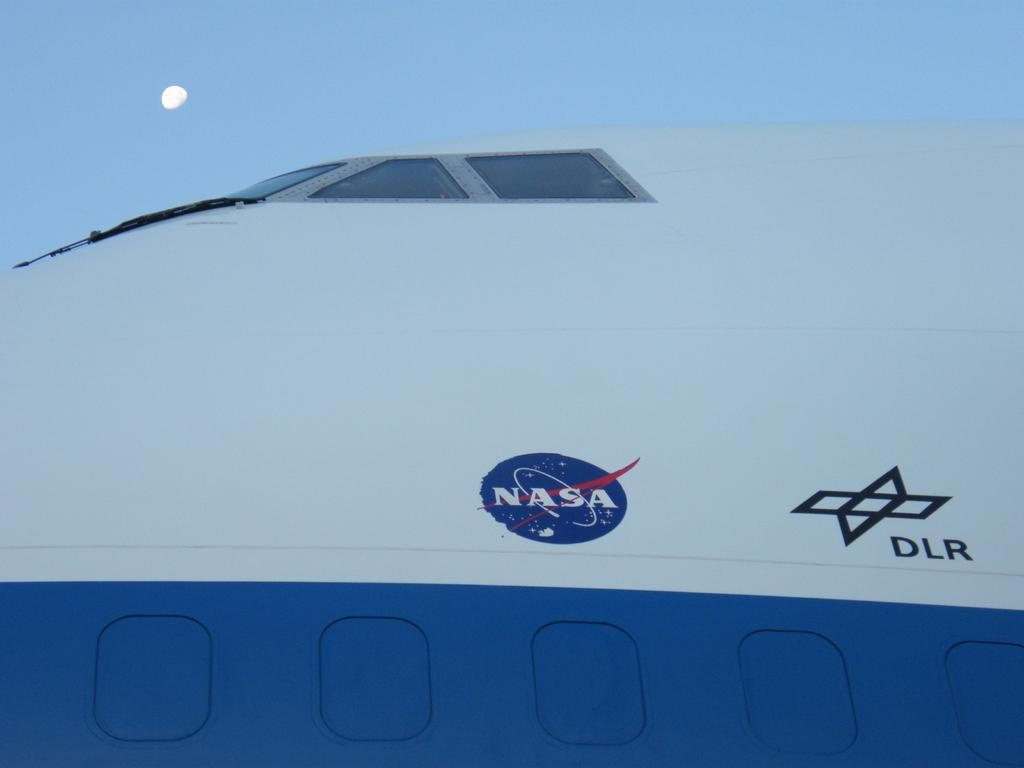<image>
Write a terse but informative summary of the picture. A white and blue shuttle with the NASA logo on it 